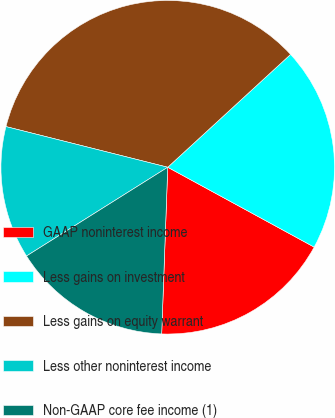Convert chart to OTSL. <chart><loc_0><loc_0><loc_500><loc_500><pie_chart><fcel>GAAP noninterest income<fcel>Less gains on investment<fcel>Less gains on equity warrant<fcel>Less other noninterest income<fcel>Non-GAAP core fee income (1)<nl><fcel>17.63%<fcel>19.77%<fcel>34.25%<fcel>12.85%<fcel>15.49%<nl></chart> 